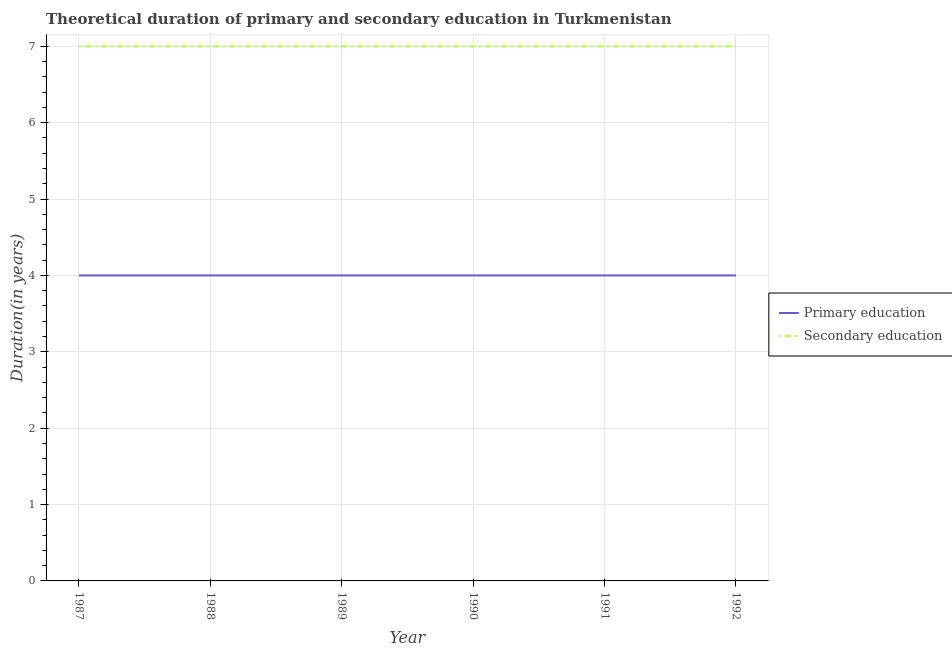Does the line corresponding to duration of secondary education intersect with the line corresponding to duration of primary education?
Your answer should be very brief. No. Is the number of lines equal to the number of legend labels?
Your response must be concise. Yes. What is the duration of secondary education in 1988?
Your answer should be very brief. 7. Across all years, what is the maximum duration of primary education?
Your response must be concise. 4. Across all years, what is the minimum duration of primary education?
Provide a succinct answer. 4. In which year was the duration of primary education maximum?
Offer a very short reply. 1987. What is the total duration of secondary education in the graph?
Offer a terse response. 42. What is the difference between the duration of secondary education in 1991 and the duration of primary education in 1988?
Make the answer very short. 3. In the year 1992, what is the difference between the duration of primary education and duration of secondary education?
Give a very brief answer. -3. In how many years, is the duration of secondary education greater than 4 years?
Keep it short and to the point. 6. What is the ratio of the duration of primary education in 1988 to that in 1990?
Provide a short and direct response. 1. Is the duration of primary education in 1987 less than that in 1990?
Your answer should be very brief. No. Is the difference between the duration of secondary education in 1990 and 1991 greater than the difference between the duration of primary education in 1990 and 1991?
Give a very brief answer. No. What is the difference between the highest and the second highest duration of secondary education?
Provide a succinct answer. 0. What is the difference between the highest and the lowest duration of secondary education?
Make the answer very short. 0. Does the duration of primary education monotonically increase over the years?
Provide a succinct answer. No. Is the duration of secondary education strictly greater than the duration of primary education over the years?
Give a very brief answer. Yes. Is the duration of secondary education strictly less than the duration of primary education over the years?
Give a very brief answer. No. Are the values on the major ticks of Y-axis written in scientific E-notation?
Your response must be concise. No. Where does the legend appear in the graph?
Provide a short and direct response. Center right. How many legend labels are there?
Make the answer very short. 2. How are the legend labels stacked?
Provide a short and direct response. Vertical. What is the title of the graph?
Give a very brief answer. Theoretical duration of primary and secondary education in Turkmenistan. What is the label or title of the X-axis?
Keep it short and to the point. Year. What is the label or title of the Y-axis?
Offer a terse response. Duration(in years). What is the Duration(in years) in Secondary education in 1987?
Your response must be concise. 7. What is the Duration(in years) of Secondary education in 1988?
Offer a very short reply. 7. What is the Duration(in years) in Primary education in 1990?
Keep it short and to the point. 4. What is the Duration(in years) of Secondary education in 1990?
Your response must be concise. 7. What is the Duration(in years) of Secondary education in 1991?
Make the answer very short. 7. What is the Duration(in years) of Primary education in 1992?
Your answer should be very brief. 4. What is the Duration(in years) in Secondary education in 1992?
Make the answer very short. 7. Across all years, what is the maximum Duration(in years) in Secondary education?
Your answer should be compact. 7. Across all years, what is the minimum Duration(in years) of Primary education?
Make the answer very short. 4. Across all years, what is the minimum Duration(in years) in Secondary education?
Give a very brief answer. 7. What is the difference between the Duration(in years) of Primary education in 1987 and that in 1988?
Your answer should be very brief. 0. What is the difference between the Duration(in years) in Primary education in 1987 and that in 1989?
Give a very brief answer. 0. What is the difference between the Duration(in years) of Primary education in 1987 and that in 1990?
Make the answer very short. 0. What is the difference between the Duration(in years) of Primary education in 1987 and that in 1991?
Offer a terse response. 0. What is the difference between the Duration(in years) of Secondary education in 1987 and that in 1991?
Make the answer very short. 0. What is the difference between the Duration(in years) of Secondary education in 1987 and that in 1992?
Give a very brief answer. 0. What is the difference between the Duration(in years) of Primary education in 1988 and that in 1989?
Make the answer very short. 0. What is the difference between the Duration(in years) of Primary education in 1988 and that in 1990?
Your answer should be very brief. 0. What is the difference between the Duration(in years) of Primary education in 1988 and that in 1991?
Offer a very short reply. 0. What is the difference between the Duration(in years) of Secondary education in 1988 and that in 1991?
Your response must be concise. 0. What is the difference between the Duration(in years) in Secondary education in 1988 and that in 1992?
Offer a terse response. 0. What is the difference between the Duration(in years) in Secondary education in 1989 and that in 1991?
Ensure brevity in your answer.  0. What is the difference between the Duration(in years) of Primary education in 1991 and that in 1992?
Offer a very short reply. 0. What is the difference between the Duration(in years) in Primary education in 1987 and the Duration(in years) in Secondary education in 1990?
Your answer should be compact. -3. What is the difference between the Duration(in years) of Primary education in 1987 and the Duration(in years) of Secondary education in 1992?
Your answer should be compact. -3. What is the difference between the Duration(in years) in Primary education in 1988 and the Duration(in years) in Secondary education in 1990?
Offer a terse response. -3. What is the difference between the Duration(in years) of Primary education in 1988 and the Duration(in years) of Secondary education in 1991?
Offer a very short reply. -3. What is the difference between the Duration(in years) of Primary education in 1988 and the Duration(in years) of Secondary education in 1992?
Your response must be concise. -3. What is the difference between the Duration(in years) of Primary education in 1990 and the Duration(in years) of Secondary education in 1992?
Offer a very short reply. -3. What is the difference between the Duration(in years) in Primary education in 1991 and the Duration(in years) in Secondary education in 1992?
Your answer should be very brief. -3. In the year 1989, what is the difference between the Duration(in years) of Primary education and Duration(in years) of Secondary education?
Ensure brevity in your answer.  -3. In the year 1990, what is the difference between the Duration(in years) of Primary education and Duration(in years) of Secondary education?
Your answer should be compact. -3. What is the ratio of the Duration(in years) of Secondary education in 1987 to that in 1988?
Provide a short and direct response. 1. What is the ratio of the Duration(in years) of Primary education in 1987 to that in 1989?
Offer a terse response. 1. What is the ratio of the Duration(in years) of Primary education in 1987 to that in 1990?
Provide a short and direct response. 1. What is the ratio of the Duration(in years) in Secondary education in 1987 to that in 1990?
Make the answer very short. 1. What is the ratio of the Duration(in years) in Primary education in 1987 to that in 1991?
Offer a very short reply. 1. What is the ratio of the Duration(in years) in Secondary education in 1987 to that in 1991?
Your response must be concise. 1. What is the ratio of the Duration(in years) of Secondary education in 1987 to that in 1992?
Make the answer very short. 1. What is the ratio of the Duration(in years) of Primary education in 1988 to that in 1989?
Provide a short and direct response. 1. What is the ratio of the Duration(in years) of Secondary education in 1988 to that in 1991?
Provide a short and direct response. 1. What is the ratio of the Duration(in years) in Secondary education in 1988 to that in 1992?
Provide a short and direct response. 1. What is the ratio of the Duration(in years) of Primary education in 1989 to that in 1990?
Provide a short and direct response. 1. What is the ratio of the Duration(in years) in Secondary education in 1989 to that in 1991?
Your answer should be compact. 1. What is the ratio of the Duration(in years) in Primary education in 1990 to that in 1991?
Offer a very short reply. 1. What is the ratio of the Duration(in years) in Primary education in 1990 to that in 1992?
Make the answer very short. 1. What is the ratio of the Duration(in years) of Secondary education in 1990 to that in 1992?
Give a very brief answer. 1. What is the ratio of the Duration(in years) in Primary education in 1991 to that in 1992?
Offer a very short reply. 1. What is the difference between the highest and the second highest Duration(in years) of Primary education?
Provide a short and direct response. 0. What is the difference between the highest and the lowest Duration(in years) in Primary education?
Offer a very short reply. 0. What is the difference between the highest and the lowest Duration(in years) of Secondary education?
Your answer should be compact. 0. 